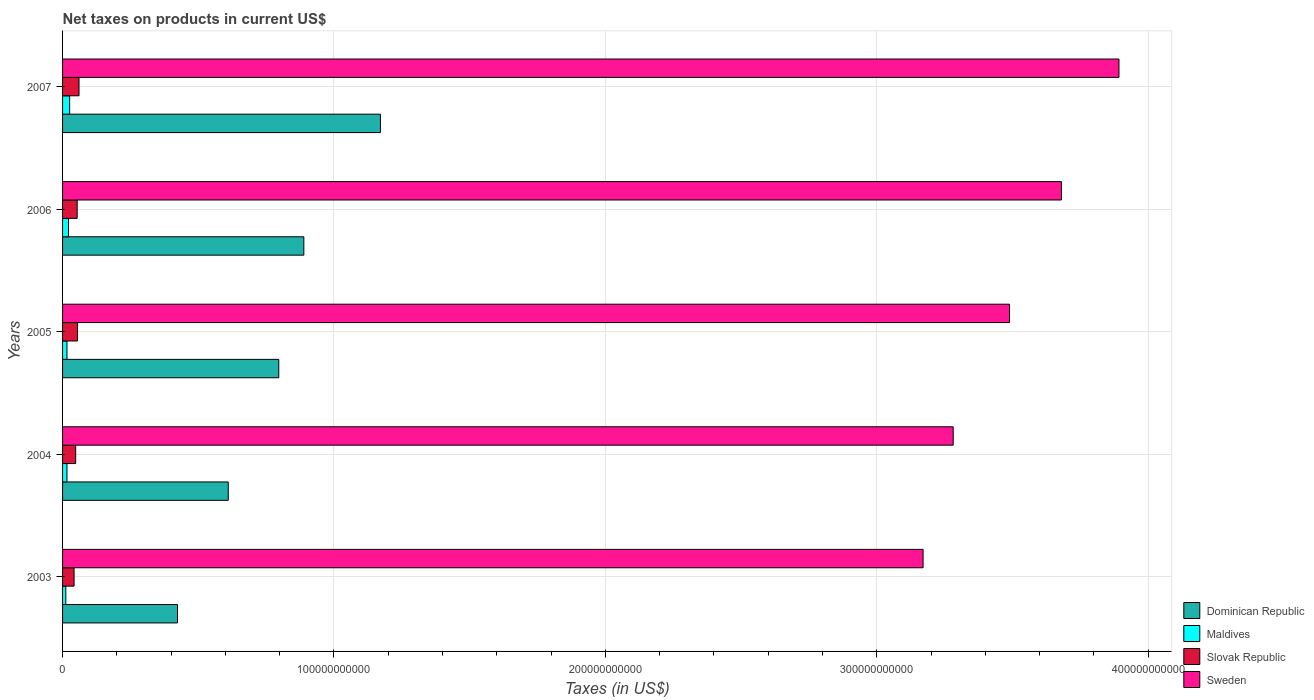Are the number of bars on each tick of the Y-axis equal?
Give a very brief answer. Yes. How many bars are there on the 1st tick from the bottom?
Offer a very short reply. 4. In how many cases, is the number of bars for a given year not equal to the number of legend labels?
Keep it short and to the point. 0. What is the net taxes on products in Dominican Republic in 2006?
Your answer should be very brief. 8.89e+1. Across all years, what is the maximum net taxes on products in Dominican Republic?
Offer a terse response. 1.17e+11. Across all years, what is the minimum net taxes on products in Maldives?
Make the answer very short. 1.20e+09. What is the total net taxes on products in Slovak Republic in the graph?
Offer a terse response. 2.60e+1. What is the difference between the net taxes on products in Maldives in 2006 and that in 2007?
Give a very brief answer. -4.19e+08. What is the difference between the net taxes on products in Sweden in 2004 and the net taxes on products in Dominican Republic in 2005?
Your answer should be very brief. 2.49e+11. What is the average net taxes on products in Dominican Republic per year?
Offer a very short reply. 7.78e+1. In the year 2006, what is the difference between the net taxes on products in Slovak Republic and net taxes on products in Maldives?
Give a very brief answer. 3.19e+09. What is the ratio of the net taxes on products in Maldives in 2005 to that in 2006?
Give a very brief answer. 0.74. Is the difference between the net taxes on products in Slovak Republic in 2004 and 2005 greater than the difference between the net taxes on products in Maldives in 2004 and 2005?
Provide a short and direct response. No. What is the difference between the highest and the second highest net taxes on products in Slovak Republic?
Make the answer very short. 5.53e+08. What is the difference between the highest and the lowest net taxes on products in Sweden?
Your response must be concise. 7.22e+1. In how many years, is the net taxes on products in Slovak Republic greater than the average net taxes on products in Slovak Republic taken over all years?
Keep it short and to the point. 3. Is it the case that in every year, the sum of the net taxes on products in Slovak Republic and net taxes on products in Sweden is greater than the sum of net taxes on products in Maldives and net taxes on products in Dominican Republic?
Make the answer very short. Yes. What does the 4th bar from the top in 2003 represents?
Ensure brevity in your answer.  Dominican Republic. What does the 1st bar from the bottom in 2005 represents?
Give a very brief answer. Dominican Republic. How many bars are there?
Your response must be concise. 20. What is the difference between two consecutive major ticks on the X-axis?
Ensure brevity in your answer.  1.00e+11. Are the values on the major ticks of X-axis written in scientific E-notation?
Your answer should be very brief. No. Where does the legend appear in the graph?
Provide a succinct answer. Bottom right. How many legend labels are there?
Your response must be concise. 4. What is the title of the graph?
Give a very brief answer. Net taxes on products in current US$. Does "Serbia" appear as one of the legend labels in the graph?
Keep it short and to the point. No. What is the label or title of the X-axis?
Your answer should be compact. Taxes (in US$). What is the label or title of the Y-axis?
Your answer should be compact. Years. What is the Taxes (in US$) in Dominican Republic in 2003?
Provide a short and direct response. 4.24e+1. What is the Taxes (in US$) of Maldives in 2003?
Provide a short and direct response. 1.20e+09. What is the Taxes (in US$) in Slovak Republic in 2003?
Make the answer very short. 4.24e+09. What is the Taxes (in US$) of Sweden in 2003?
Provide a succinct answer. 3.17e+11. What is the Taxes (in US$) of Dominican Republic in 2004?
Your response must be concise. 6.10e+1. What is the Taxes (in US$) of Maldives in 2004?
Keep it short and to the point. 1.62e+09. What is the Taxes (in US$) of Slovak Republic in 2004?
Provide a succinct answer. 4.83e+09. What is the Taxes (in US$) of Sweden in 2004?
Your answer should be very brief. 3.28e+11. What is the Taxes (in US$) in Dominican Republic in 2005?
Keep it short and to the point. 7.97e+1. What is the Taxes (in US$) of Maldives in 2005?
Offer a terse response. 1.63e+09. What is the Taxes (in US$) in Slovak Republic in 2005?
Ensure brevity in your answer.  5.51e+09. What is the Taxes (in US$) in Sweden in 2005?
Offer a terse response. 3.49e+11. What is the Taxes (in US$) of Dominican Republic in 2006?
Offer a very short reply. 8.89e+1. What is the Taxes (in US$) of Maldives in 2006?
Your response must be concise. 2.19e+09. What is the Taxes (in US$) in Slovak Republic in 2006?
Provide a short and direct response. 5.38e+09. What is the Taxes (in US$) in Sweden in 2006?
Your response must be concise. 3.68e+11. What is the Taxes (in US$) in Dominican Republic in 2007?
Your response must be concise. 1.17e+11. What is the Taxes (in US$) in Maldives in 2007?
Make the answer very short. 2.61e+09. What is the Taxes (in US$) in Slovak Republic in 2007?
Give a very brief answer. 6.06e+09. What is the Taxes (in US$) of Sweden in 2007?
Provide a short and direct response. 3.89e+11. Across all years, what is the maximum Taxes (in US$) in Dominican Republic?
Your answer should be very brief. 1.17e+11. Across all years, what is the maximum Taxes (in US$) of Maldives?
Your answer should be very brief. 2.61e+09. Across all years, what is the maximum Taxes (in US$) in Slovak Republic?
Ensure brevity in your answer.  6.06e+09. Across all years, what is the maximum Taxes (in US$) in Sweden?
Provide a succinct answer. 3.89e+11. Across all years, what is the minimum Taxes (in US$) in Dominican Republic?
Your answer should be very brief. 4.24e+1. Across all years, what is the minimum Taxes (in US$) of Maldives?
Keep it short and to the point. 1.20e+09. Across all years, what is the minimum Taxes (in US$) in Slovak Republic?
Your answer should be compact. 4.24e+09. Across all years, what is the minimum Taxes (in US$) in Sweden?
Offer a very short reply. 3.17e+11. What is the total Taxes (in US$) in Dominican Republic in the graph?
Offer a very short reply. 3.89e+11. What is the total Taxes (in US$) of Maldives in the graph?
Ensure brevity in your answer.  9.25e+09. What is the total Taxes (in US$) in Slovak Republic in the graph?
Your answer should be compact. 2.60e+1. What is the total Taxes (in US$) in Sweden in the graph?
Your answer should be compact. 1.75e+12. What is the difference between the Taxes (in US$) in Dominican Republic in 2003 and that in 2004?
Give a very brief answer. -1.87e+1. What is the difference between the Taxes (in US$) in Maldives in 2003 and that in 2004?
Keep it short and to the point. -4.24e+08. What is the difference between the Taxes (in US$) in Slovak Republic in 2003 and that in 2004?
Provide a succinct answer. -5.83e+08. What is the difference between the Taxes (in US$) in Sweden in 2003 and that in 2004?
Make the answer very short. -1.11e+1. What is the difference between the Taxes (in US$) in Dominican Republic in 2003 and that in 2005?
Make the answer very short. -3.73e+1. What is the difference between the Taxes (in US$) in Maldives in 2003 and that in 2005?
Your answer should be very brief. -4.33e+08. What is the difference between the Taxes (in US$) of Slovak Republic in 2003 and that in 2005?
Your answer should be very brief. -1.27e+09. What is the difference between the Taxes (in US$) of Sweden in 2003 and that in 2005?
Keep it short and to the point. -3.18e+1. What is the difference between the Taxes (in US$) of Dominican Republic in 2003 and that in 2006?
Offer a very short reply. -4.66e+1. What is the difference between the Taxes (in US$) of Maldives in 2003 and that in 2006?
Keep it short and to the point. -9.96e+08. What is the difference between the Taxes (in US$) of Slovak Republic in 2003 and that in 2006?
Give a very brief answer. -1.14e+09. What is the difference between the Taxes (in US$) in Sweden in 2003 and that in 2006?
Offer a very short reply. -5.10e+1. What is the difference between the Taxes (in US$) of Dominican Republic in 2003 and that in 2007?
Your response must be concise. -7.48e+1. What is the difference between the Taxes (in US$) in Maldives in 2003 and that in 2007?
Make the answer very short. -1.41e+09. What is the difference between the Taxes (in US$) of Slovak Republic in 2003 and that in 2007?
Offer a terse response. -1.82e+09. What is the difference between the Taxes (in US$) in Sweden in 2003 and that in 2007?
Your answer should be compact. -7.22e+1. What is the difference between the Taxes (in US$) in Dominican Republic in 2004 and that in 2005?
Your response must be concise. -1.86e+1. What is the difference between the Taxes (in US$) in Maldives in 2004 and that in 2005?
Ensure brevity in your answer.  -8.93e+06. What is the difference between the Taxes (in US$) in Slovak Republic in 2004 and that in 2005?
Make the answer very short. -6.82e+08. What is the difference between the Taxes (in US$) of Sweden in 2004 and that in 2005?
Your response must be concise. -2.08e+1. What is the difference between the Taxes (in US$) of Dominican Republic in 2004 and that in 2006?
Offer a terse response. -2.79e+1. What is the difference between the Taxes (in US$) of Maldives in 2004 and that in 2006?
Provide a short and direct response. -5.72e+08. What is the difference between the Taxes (in US$) in Slovak Republic in 2004 and that in 2006?
Your response must be concise. -5.57e+08. What is the difference between the Taxes (in US$) of Sweden in 2004 and that in 2006?
Ensure brevity in your answer.  -3.99e+1. What is the difference between the Taxes (in US$) in Dominican Republic in 2004 and that in 2007?
Your answer should be very brief. -5.61e+1. What is the difference between the Taxes (in US$) in Maldives in 2004 and that in 2007?
Provide a succinct answer. -9.91e+08. What is the difference between the Taxes (in US$) in Slovak Republic in 2004 and that in 2007?
Your answer should be compact. -1.24e+09. What is the difference between the Taxes (in US$) in Sweden in 2004 and that in 2007?
Provide a succinct answer. -6.11e+1. What is the difference between the Taxes (in US$) of Dominican Republic in 2005 and that in 2006?
Your response must be concise. -9.24e+09. What is the difference between the Taxes (in US$) of Maldives in 2005 and that in 2006?
Keep it short and to the point. -5.63e+08. What is the difference between the Taxes (in US$) of Slovak Republic in 2005 and that in 2006?
Keep it short and to the point. 1.25e+08. What is the difference between the Taxes (in US$) of Sweden in 2005 and that in 2006?
Provide a short and direct response. -1.91e+1. What is the difference between the Taxes (in US$) in Dominican Republic in 2005 and that in 2007?
Your answer should be compact. -3.75e+1. What is the difference between the Taxes (in US$) in Maldives in 2005 and that in 2007?
Provide a succinct answer. -9.82e+08. What is the difference between the Taxes (in US$) in Slovak Republic in 2005 and that in 2007?
Your answer should be compact. -5.53e+08. What is the difference between the Taxes (in US$) in Sweden in 2005 and that in 2007?
Offer a terse response. -4.03e+1. What is the difference between the Taxes (in US$) in Dominican Republic in 2006 and that in 2007?
Your answer should be very brief. -2.82e+1. What is the difference between the Taxes (in US$) of Maldives in 2006 and that in 2007?
Make the answer very short. -4.19e+08. What is the difference between the Taxes (in US$) in Slovak Republic in 2006 and that in 2007?
Make the answer very short. -6.78e+08. What is the difference between the Taxes (in US$) in Sweden in 2006 and that in 2007?
Your response must be concise. -2.12e+1. What is the difference between the Taxes (in US$) in Dominican Republic in 2003 and the Taxes (in US$) in Maldives in 2004?
Your response must be concise. 4.07e+1. What is the difference between the Taxes (in US$) in Dominican Republic in 2003 and the Taxes (in US$) in Slovak Republic in 2004?
Provide a short and direct response. 3.75e+1. What is the difference between the Taxes (in US$) of Dominican Republic in 2003 and the Taxes (in US$) of Sweden in 2004?
Keep it short and to the point. -2.86e+11. What is the difference between the Taxes (in US$) of Maldives in 2003 and the Taxes (in US$) of Slovak Republic in 2004?
Make the answer very short. -3.63e+09. What is the difference between the Taxes (in US$) in Maldives in 2003 and the Taxes (in US$) in Sweden in 2004?
Offer a terse response. -3.27e+11. What is the difference between the Taxes (in US$) of Slovak Republic in 2003 and the Taxes (in US$) of Sweden in 2004?
Make the answer very short. -3.24e+11. What is the difference between the Taxes (in US$) in Dominican Republic in 2003 and the Taxes (in US$) in Maldives in 2005?
Give a very brief answer. 4.07e+1. What is the difference between the Taxes (in US$) of Dominican Republic in 2003 and the Taxes (in US$) of Slovak Republic in 2005?
Offer a very short reply. 3.68e+1. What is the difference between the Taxes (in US$) of Dominican Republic in 2003 and the Taxes (in US$) of Sweden in 2005?
Ensure brevity in your answer.  -3.07e+11. What is the difference between the Taxes (in US$) of Maldives in 2003 and the Taxes (in US$) of Slovak Republic in 2005?
Your response must be concise. -4.31e+09. What is the difference between the Taxes (in US$) in Maldives in 2003 and the Taxes (in US$) in Sweden in 2005?
Make the answer very short. -3.48e+11. What is the difference between the Taxes (in US$) in Slovak Republic in 2003 and the Taxes (in US$) in Sweden in 2005?
Offer a terse response. -3.45e+11. What is the difference between the Taxes (in US$) in Dominican Republic in 2003 and the Taxes (in US$) in Maldives in 2006?
Give a very brief answer. 4.02e+1. What is the difference between the Taxes (in US$) in Dominican Republic in 2003 and the Taxes (in US$) in Slovak Republic in 2006?
Your answer should be very brief. 3.70e+1. What is the difference between the Taxes (in US$) of Dominican Republic in 2003 and the Taxes (in US$) of Sweden in 2006?
Your response must be concise. -3.26e+11. What is the difference between the Taxes (in US$) in Maldives in 2003 and the Taxes (in US$) in Slovak Republic in 2006?
Give a very brief answer. -4.19e+09. What is the difference between the Taxes (in US$) in Maldives in 2003 and the Taxes (in US$) in Sweden in 2006?
Your answer should be very brief. -3.67e+11. What is the difference between the Taxes (in US$) in Slovak Republic in 2003 and the Taxes (in US$) in Sweden in 2006?
Offer a terse response. -3.64e+11. What is the difference between the Taxes (in US$) in Dominican Republic in 2003 and the Taxes (in US$) in Maldives in 2007?
Your answer should be very brief. 3.97e+1. What is the difference between the Taxes (in US$) of Dominican Republic in 2003 and the Taxes (in US$) of Slovak Republic in 2007?
Ensure brevity in your answer.  3.63e+1. What is the difference between the Taxes (in US$) in Dominican Republic in 2003 and the Taxes (in US$) in Sweden in 2007?
Offer a very short reply. -3.47e+11. What is the difference between the Taxes (in US$) in Maldives in 2003 and the Taxes (in US$) in Slovak Republic in 2007?
Give a very brief answer. -4.87e+09. What is the difference between the Taxes (in US$) in Maldives in 2003 and the Taxes (in US$) in Sweden in 2007?
Your answer should be very brief. -3.88e+11. What is the difference between the Taxes (in US$) of Slovak Republic in 2003 and the Taxes (in US$) of Sweden in 2007?
Ensure brevity in your answer.  -3.85e+11. What is the difference between the Taxes (in US$) of Dominican Republic in 2004 and the Taxes (in US$) of Maldives in 2005?
Offer a very short reply. 5.94e+1. What is the difference between the Taxes (in US$) in Dominican Republic in 2004 and the Taxes (in US$) in Slovak Republic in 2005?
Provide a succinct answer. 5.55e+1. What is the difference between the Taxes (in US$) in Dominican Republic in 2004 and the Taxes (in US$) in Sweden in 2005?
Provide a succinct answer. -2.88e+11. What is the difference between the Taxes (in US$) of Maldives in 2004 and the Taxes (in US$) of Slovak Republic in 2005?
Your answer should be compact. -3.89e+09. What is the difference between the Taxes (in US$) in Maldives in 2004 and the Taxes (in US$) in Sweden in 2005?
Offer a very short reply. -3.47e+11. What is the difference between the Taxes (in US$) of Slovak Republic in 2004 and the Taxes (in US$) of Sweden in 2005?
Your answer should be very brief. -3.44e+11. What is the difference between the Taxes (in US$) of Dominican Republic in 2004 and the Taxes (in US$) of Maldives in 2006?
Provide a short and direct response. 5.89e+1. What is the difference between the Taxes (in US$) of Dominican Republic in 2004 and the Taxes (in US$) of Slovak Republic in 2006?
Keep it short and to the point. 5.57e+1. What is the difference between the Taxes (in US$) in Dominican Republic in 2004 and the Taxes (in US$) in Sweden in 2006?
Offer a terse response. -3.07e+11. What is the difference between the Taxes (in US$) of Maldives in 2004 and the Taxes (in US$) of Slovak Republic in 2006?
Your answer should be compact. -3.76e+09. What is the difference between the Taxes (in US$) in Maldives in 2004 and the Taxes (in US$) in Sweden in 2006?
Your answer should be compact. -3.66e+11. What is the difference between the Taxes (in US$) of Slovak Republic in 2004 and the Taxes (in US$) of Sweden in 2006?
Provide a short and direct response. -3.63e+11. What is the difference between the Taxes (in US$) in Dominican Republic in 2004 and the Taxes (in US$) in Maldives in 2007?
Your response must be concise. 5.84e+1. What is the difference between the Taxes (in US$) of Dominican Republic in 2004 and the Taxes (in US$) of Slovak Republic in 2007?
Your answer should be very brief. 5.50e+1. What is the difference between the Taxes (in US$) of Dominican Republic in 2004 and the Taxes (in US$) of Sweden in 2007?
Offer a very short reply. -3.28e+11. What is the difference between the Taxes (in US$) of Maldives in 2004 and the Taxes (in US$) of Slovak Republic in 2007?
Offer a very short reply. -4.44e+09. What is the difference between the Taxes (in US$) in Maldives in 2004 and the Taxes (in US$) in Sweden in 2007?
Ensure brevity in your answer.  -3.88e+11. What is the difference between the Taxes (in US$) in Slovak Republic in 2004 and the Taxes (in US$) in Sweden in 2007?
Offer a very short reply. -3.84e+11. What is the difference between the Taxes (in US$) in Dominican Republic in 2005 and the Taxes (in US$) in Maldives in 2006?
Offer a very short reply. 7.75e+1. What is the difference between the Taxes (in US$) of Dominican Republic in 2005 and the Taxes (in US$) of Slovak Republic in 2006?
Offer a very short reply. 7.43e+1. What is the difference between the Taxes (in US$) in Dominican Republic in 2005 and the Taxes (in US$) in Sweden in 2006?
Offer a terse response. -2.88e+11. What is the difference between the Taxes (in US$) in Maldives in 2005 and the Taxes (in US$) in Slovak Republic in 2006?
Provide a succinct answer. -3.75e+09. What is the difference between the Taxes (in US$) of Maldives in 2005 and the Taxes (in US$) of Sweden in 2006?
Provide a succinct answer. -3.66e+11. What is the difference between the Taxes (in US$) of Slovak Republic in 2005 and the Taxes (in US$) of Sweden in 2006?
Provide a short and direct response. -3.63e+11. What is the difference between the Taxes (in US$) of Dominican Republic in 2005 and the Taxes (in US$) of Maldives in 2007?
Your response must be concise. 7.71e+1. What is the difference between the Taxes (in US$) in Dominican Republic in 2005 and the Taxes (in US$) in Slovak Republic in 2007?
Your answer should be very brief. 7.36e+1. What is the difference between the Taxes (in US$) in Dominican Republic in 2005 and the Taxes (in US$) in Sweden in 2007?
Make the answer very short. -3.10e+11. What is the difference between the Taxes (in US$) in Maldives in 2005 and the Taxes (in US$) in Slovak Republic in 2007?
Provide a short and direct response. -4.43e+09. What is the difference between the Taxes (in US$) of Maldives in 2005 and the Taxes (in US$) of Sweden in 2007?
Offer a very short reply. -3.88e+11. What is the difference between the Taxes (in US$) of Slovak Republic in 2005 and the Taxes (in US$) of Sweden in 2007?
Your response must be concise. -3.84e+11. What is the difference between the Taxes (in US$) in Dominican Republic in 2006 and the Taxes (in US$) in Maldives in 2007?
Provide a short and direct response. 8.63e+1. What is the difference between the Taxes (in US$) in Dominican Republic in 2006 and the Taxes (in US$) in Slovak Republic in 2007?
Keep it short and to the point. 8.28e+1. What is the difference between the Taxes (in US$) in Dominican Republic in 2006 and the Taxes (in US$) in Sweden in 2007?
Your answer should be compact. -3.00e+11. What is the difference between the Taxes (in US$) of Maldives in 2006 and the Taxes (in US$) of Slovak Republic in 2007?
Your response must be concise. -3.87e+09. What is the difference between the Taxes (in US$) of Maldives in 2006 and the Taxes (in US$) of Sweden in 2007?
Offer a very short reply. -3.87e+11. What is the difference between the Taxes (in US$) of Slovak Republic in 2006 and the Taxes (in US$) of Sweden in 2007?
Make the answer very short. -3.84e+11. What is the average Taxes (in US$) in Dominican Republic per year?
Offer a very short reply. 7.78e+1. What is the average Taxes (in US$) in Maldives per year?
Provide a short and direct response. 1.85e+09. What is the average Taxes (in US$) in Slovak Republic per year?
Your answer should be compact. 5.21e+09. What is the average Taxes (in US$) of Sweden per year?
Your answer should be very brief. 3.50e+11. In the year 2003, what is the difference between the Taxes (in US$) of Dominican Republic and Taxes (in US$) of Maldives?
Ensure brevity in your answer.  4.12e+1. In the year 2003, what is the difference between the Taxes (in US$) of Dominican Republic and Taxes (in US$) of Slovak Republic?
Your answer should be compact. 3.81e+1. In the year 2003, what is the difference between the Taxes (in US$) of Dominican Republic and Taxes (in US$) of Sweden?
Your answer should be very brief. -2.75e+11. In the year 2003, what is the difference between the Taxes (in US$) of Maldives and Taxes (in US$) of Slovak Republic?
Ensure brevity in your answer.  -3.05e+09. In the year 2003, what is the difference between the Taxes (in US$) of Maldives and Taxes (in US$) of Sweden?
Your answer should be very brief. -3.16e+11. In the year 2003, what is the difference between the Taxes (in US$) in Slovak Republic and Taxes (in US$) in Sweden?
Ensure brevity in your answer.  -3.13e+11. In the year 2004, what is the difference between the Taxes (in US$) of Dominican Republic and Taxes (in US$) of Maldives?
Provide a succinct answer. 5.94e+1. In the year 2004, what is the difference between the Taxes (in US$) in Dominican Republic and Taxes (in US$) in Slovak Republic?
Provide a short and direct response. 5.62e+1. In the year 2004, what is the difference between the Taxes (in US$) in Dominican Republic and Taxes (in US$) in Sweden?
Your answer should be compact. -2.67e+11. In the year 2004, what is the difference between the Taxes (in US$) in Maldives and Taxes (in US$) in Slovak Republic?
Provide a short and direct response. -3.21e+09. In the year 2004, what is the difference between the Taxes (in US$) of Maldives and Taxes (in US$) of Sweden?
Provide a short and direct response. -3.27e+11. In the year 2004, what is the difference between the Taxes (in US$) of Slovak Republic and Taxes (in US$) of Sweden?
Keep it short and to the point. -3.23e+11. In the year 2005, what is the difference between the Taxes (in US$) in Dominican Republic and Taxes (in US$) in Maldives?
Keep it short and to the point. 7.80e+1. In the year 2005, what is the difference between the Taxes (in US$) of Dominican Republic and Taxes (in US$) of Slovak Republic?
Offer a very short reply. 7.42e+1. In the year 2005, what is the difference between the Taxes (in US$) of Dominican Republic and Taxes (in US$) of Sweden?
Provide a short and direct response. -2.69e+11. In the year 2005, what is the difference between the Taxes (in US$) in Maldives and Taxes (in US$) in Slovak Republic?
Make the answer very short. -3.88e+09. In the year 2005, what is the difference between the Taxes (in US$) of Maldives and Taxes (in US$) of Sweden?
Offer a terse response. -3.47e+11. In the year 2005, what is the difference between the Taxes (in US$) of Slovak Republic and Taxes (in US$) of Sweden?
Give a very brief answer. -3.43e+11. In the year 2006, what is the difference between the Taxes (in US$) in Dominican Republic and Taxes (in US$) in Maldives?
Your response must be concise. 8.67e+1. In the year 2006, what is the difference between the Taxes (in US$) of Dominican Republic and Taxes (in US$) of Slovak Republic?
Offer a very short reply. 8.35e+1. In the year 2006, what is the difference between the Taxes (in US$) in Dominican Republic and Taxes (in US$) in Sweden?
Give a very brief answer. -2.79e+11. In the year 2006, what is the difference between the Taxes (in US$) in Maldives and Taxes (in US$) in Slovak Republic?
Your response must be concise. -3.19e+09. In the year 2006, what is the difference between the Taxes (in US$) in Maldives and Taxes (in US$) in Sweden?
Your answer should be compact. -3.66e+11. In the year 2006, what is the difference between the Taxes (in US$) of Slovak Republic and Taxes (in US$) of Sweden?
Give a very brief answer. -3.63e+11. In the year 2007, what is the difference between the Taxes (in US$) in Dominican Republic and Taxes (in US$) in Maldives?
Keep it short and to the point. 1.15e+11. In the year 2007, what is the difference between the Taxes (in US$) of Dominican Republic and Taxes (in US$) of Slovak Republic?
Your response must be concise. 1.11e+11. In the year 2007, what is the difference between the Taxes (in US$) in Dominican Republic and Taxes (in US$) in Sweden?
Your response must be concise. -2.72e+11. In the year 2007, what is the difference between the Taxes (in US$) of Maldives and Taxes (in US$) of Slovak Republic?
Your answer should be very brief. -3.45e+09. In the year 2007, what is the difference between the Taxes (in US$) of Maldives and Taxes (in US$) of Sweden?
Provide a short and direct response. -3.87e+11. In the year 2007, what is the difference between the Taxes (in US$) of Slovak Republic and Taxes (in US$) of Sweden?
Offer a terse response. -3.83e+11. What is the ratio of the Taxes (in US$) of Dominican Republic in 2003 to that in 2004?
Provide a short and direct response. 0.69. What is the ratio of the Taxes (in US$) of Maldives in 2003 to that in 2004?
Keep it short and to the point. 0.74. What is the ratio of the Taxes (in US$) in Slovak Republic in 2003 to that in 2004?
Offer a very short reply. 0.88. What is the ratio of the Taxes (in US$) in Sweden in 2003 to that in 2004?
Your response must be concise. 0.97. What is the ratio of the Taxes (in US$) of Dominican Republic in 2003 to that in 2005?
Your answer should be very brief. 0.53. What is the ratio of the Taxes (in US$) of Maldives in 2003 to that in 2005?
Offer a very short reply. 0.73. What is the ratio of the Taxes (in US$) in Slovak Republic in 2003 to that in 2005?
Your answer should be compact. 0.77. What is the ratio of the Taxes (in US$) of Sweden in 2003 to that in 2005?
Ensure brevity in your answer.  0.91. What is the ratio of the Taxes (in US$) in Dominican Republic in 2003 to that in 2006?
Your answer should be very brief. 0.48. What is the ratio of the Taxes (in US$) in Maldives in 2003 to that in 2006?
Keep it short and to the point. 0.55. What is the ratio of the Taxes (in US$) in Slovak Republic in 2003 to that in 2006?
Your response must be concise. 0.79. What is the ratio of the Taxes (in US$) in Sweden in 2003 to that in 2006?
Your answer should be compact. 0.86. What is the ratio of the Taxes (in US$) of Dominican Republic in 2003 to that in 2007?
Offer a terse response. 0.36. What is the ratio of the Taxes (in US$) in Maldives in 2003 to that in 2007?
Give a very brief answer. 0.46. What is the ratio of the Taxes (in US$) in Slovak Republic in 2003 to that in 2007?
Provide a short and direct response. 0.7. What is the ratio of the Taxes (in US$) in Sweden in 2003 to that in 2007?
Make the answer very short. 0.81. What is the ratio of the Taxes (in US$) of Dominican Republic in 2004 to that in 2005?
Your response must be concise. 0.77. What is the ratio of the Taxes (in US$) in Slovak Republic in 2004 to that in 2005?
Your response must be concise. 0.88. What is the ratio of the Taxes (in US$) of Sweden in 2004 to that in 2005?
Offer a terse response. 0.94. What is the ratio of the Taxes (in US$) in Dominican Republic in 2004 to that in 2006?
Make the answer very short. 0.69. What is the ratio of the Taxes (in US$) in Maldives in 2004 to that in 2006?
Provide a succinct answer. 0.74. What is the ratio of the Taxes (in US$) in Slovak Republic in 2004 to that in 2006?
Offer a terse response. 0.9. What is the ratio of the Taxes (in US$) in Sweden in 2004 to that in 2006?
Ensure brevity in your answer.  0.89. What is the ratio of the Taxes (in US$) in Dominican Republic in 2004 to that in 2007?
Make the answer very short. 0.52. What is the ratio of the Taxes (in US$) in Maldives in 2004 to that in 2007?
Make the answer very short. 0.62. What is the ratio of the Taxes (in US$) in Slovak Republic in 2004 to that in 2007?
Provide a short and direct response. 0.8. What is the ratio of the Taxes (in US$) of Sweden in 2004 to that in 2007?
Keep it short and to the point. 0.84. What is the ratio of the Taxes (in US$) of Dominican Republic in 2005 to that in 2006?
Make the answer very short. 0.9. What is the ratio of the Taxes (in US$) in Maldives in 2005 to that in 2006?
Provide a succinct answer. 0.74. What is the ratio of the Taxes (in US$) in Slovak Republic in 2005 to that in 2006?
Offer a terse response. 1.02. What is the ratio of the Taxes (in US$) of Sweden in 2005 to that in 2006?
Your answer should be very brief. 0.95. What is the ratio of the Taxes (in US$) of Dominican Republic in 2005 to that in 2007?
Provide a short and direct response. 0.68. What is the ratio of the Taxes (in US$) of Maldives in 2005 to that in 2007?
Your answer should be compact. 0.62. What is the ratio of the Taxes (in US$) of Slovak Republic in 2005 to that in 2007?
Give a very brief answer. 0.91. What is the ratio of the Taxes (in US$) of Sweden in 2005 to that in 2007?
Your answer should be very brief. 0.9. What is the ratio of the Taxes (in US$) of Dominican Republic in 2006 to that in 2007?
Provide a succinct answer. 0.76. What is the ratio of the Taxes (in US$) of Maldives in 2006 to that in 2007?
Offer a very short reply. 0.84. What is the ratio of the Taxes (in US$) in Slovak Republic in 2006 to that in 2007?
Ensure brevity in your answer.  0.89. What is the ratio of the Taxes (in US$) in Sweden in 2006 to that in 2007?
Give a very brief answer. 0.95. What is the difference between the highest and the second highest Taxes (in US$) of Dominican Republic?
Your answer should be compact. 2.82e+1. What is the difference between the highest and the second highest Taxes (in US$) in Maldives?
Keep it short and to the point. 4.19e+08. What is the difference between the highest and the second highest Taxes (in US$) in Slovak Republic?
Offer a very short reply. 5.53e+08. What is the difference between the highest and the second highest Taxes (in US$) in Sweden?
Your answer should be very brief. 2.12e+1. What is the difference between the highest and the lowest Taxes (in US$) in Dominican Republic?
Provide a succinct answer. 7.48e+1. What is the difference between the highest and the lowest Taxes (in US$) in Maldives?
Ensure brevity in your answer.  1.41e+09. What is the difference between the highest and the lowest Taxes (in US$) in Slovak Republic?
Offer a terse response. 1.82e+09. What is the difference between the highest and the lowest Taxes (in US$) of Sweden?
Give a very brief answer. 7.22e+1. 